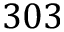Convert formula to latex. <formula><loc_0><loc_0><loc_500><loc_500>3 0 3</formula> 